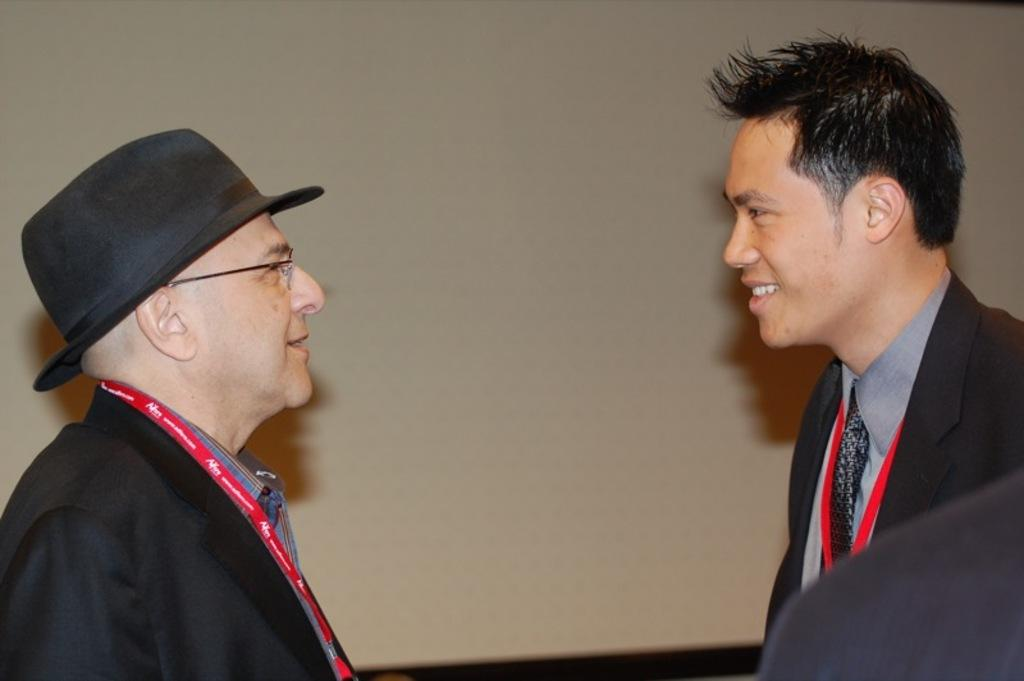How many people are in the image? There are two persons in the image. What is the person on the left wearing? The person on the left is wearing a hat. What is visible behind the persons in the image? There is a wall visible behind the persons. Can you describe the black object in the bottom right of the image? There is a black object in the bottom right of the image, but its specific details cannot be determined from the provided facts. What type of gold question is being asked by the person on the left in the image? There is no gold question being asked in the image, nor is there any indication that a story is being told. 